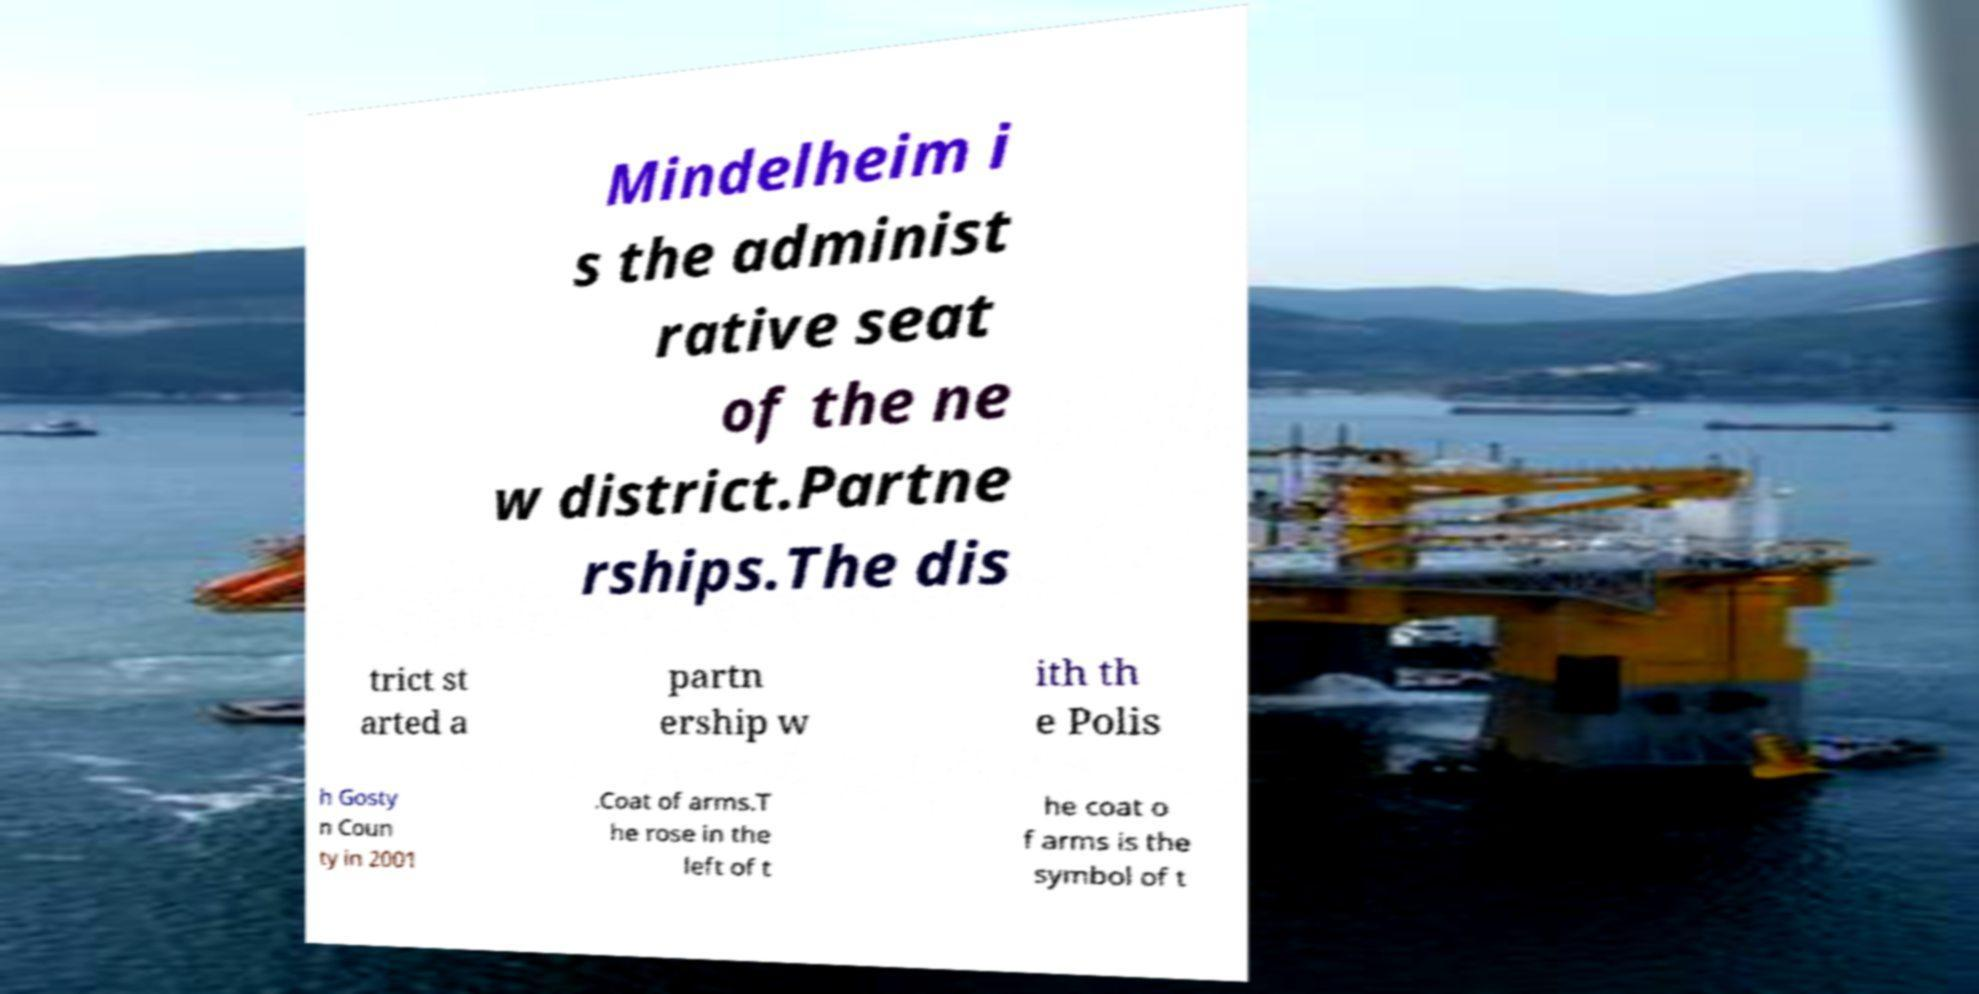What messages or text are displayed in this image? I need them in a readable, typed format. Mindelheim i s the administ rative seat of the ne w district.Partne rships.The dis trict st arted a partn ership w ith th e Polis h Gosty n Coun ty in 2001 .Coat of arms.T he rose in the left of t he coat o f arms is the symbol of t 